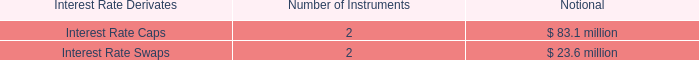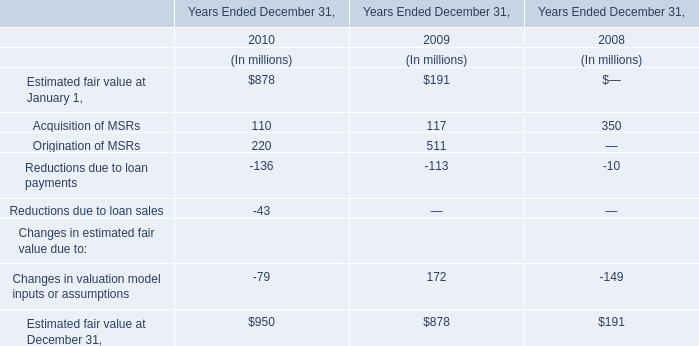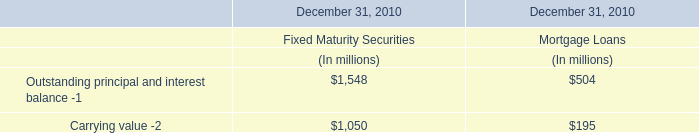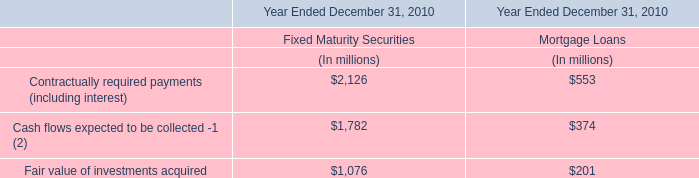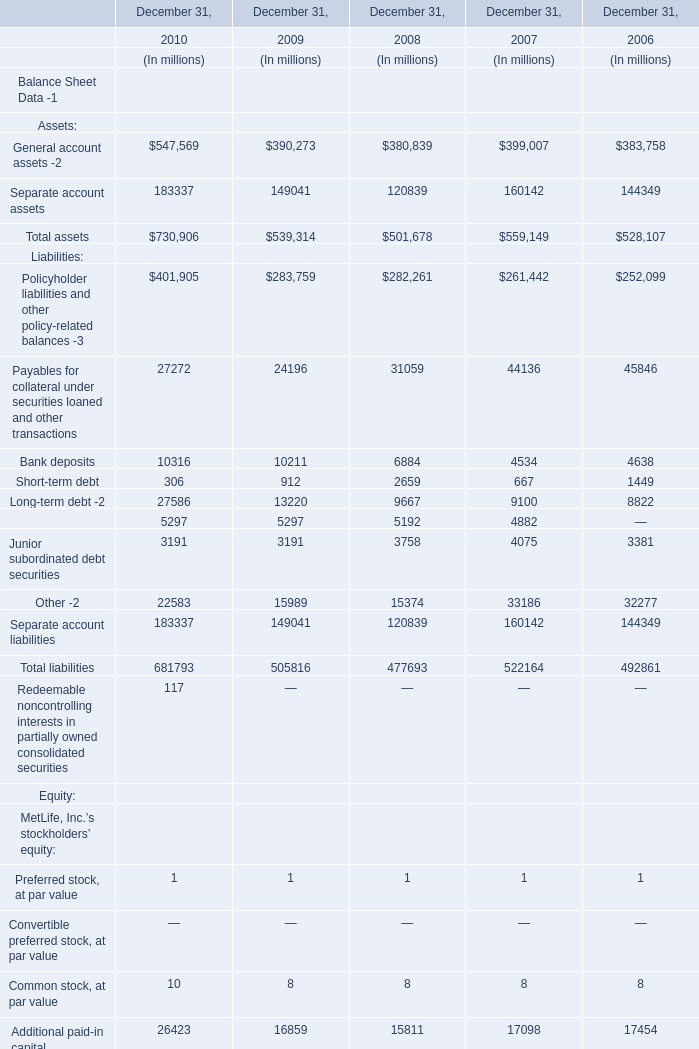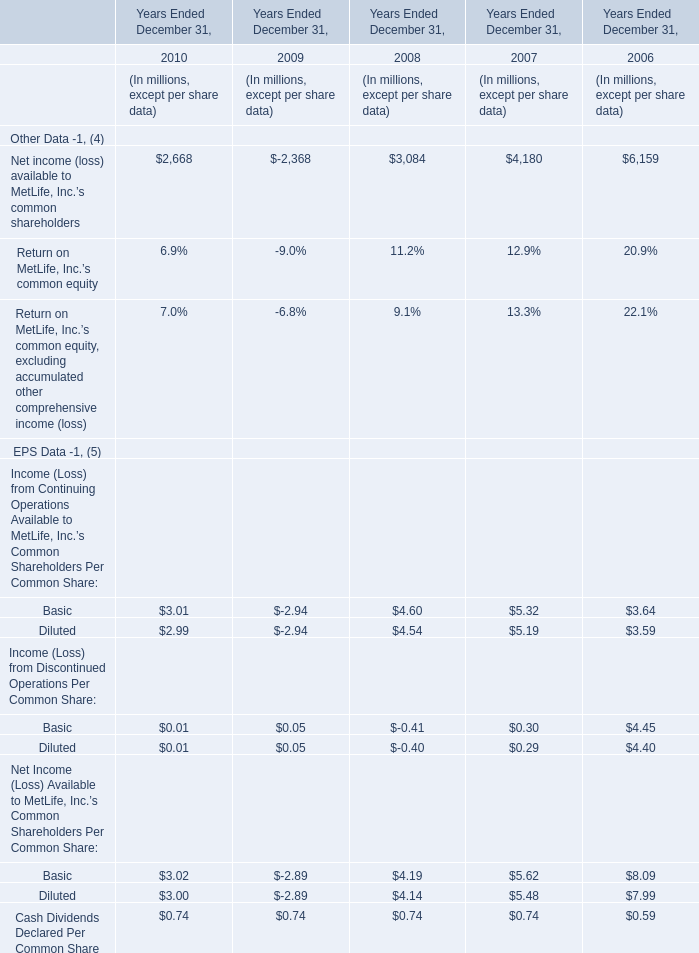What is the growth rate of Net income (loss) available to MetLife, Inc.’s common shareholders from 2006 to 2008? 
Computations: ((3084 - 6159) / 6159)
Answer: -0.49927. 